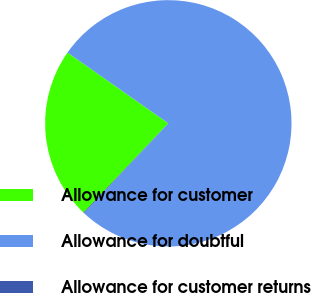Convert chart. <chart><loc_0><loc_0><loc_500><loc_500><pie_chart><fcel>Allowance for customer<fcel>Allowance for doubtful<fcel>Allowance for customer returns<nl><fcel>22.64%<fcel>77.25%<fcel>0.11%<nl></chart> 